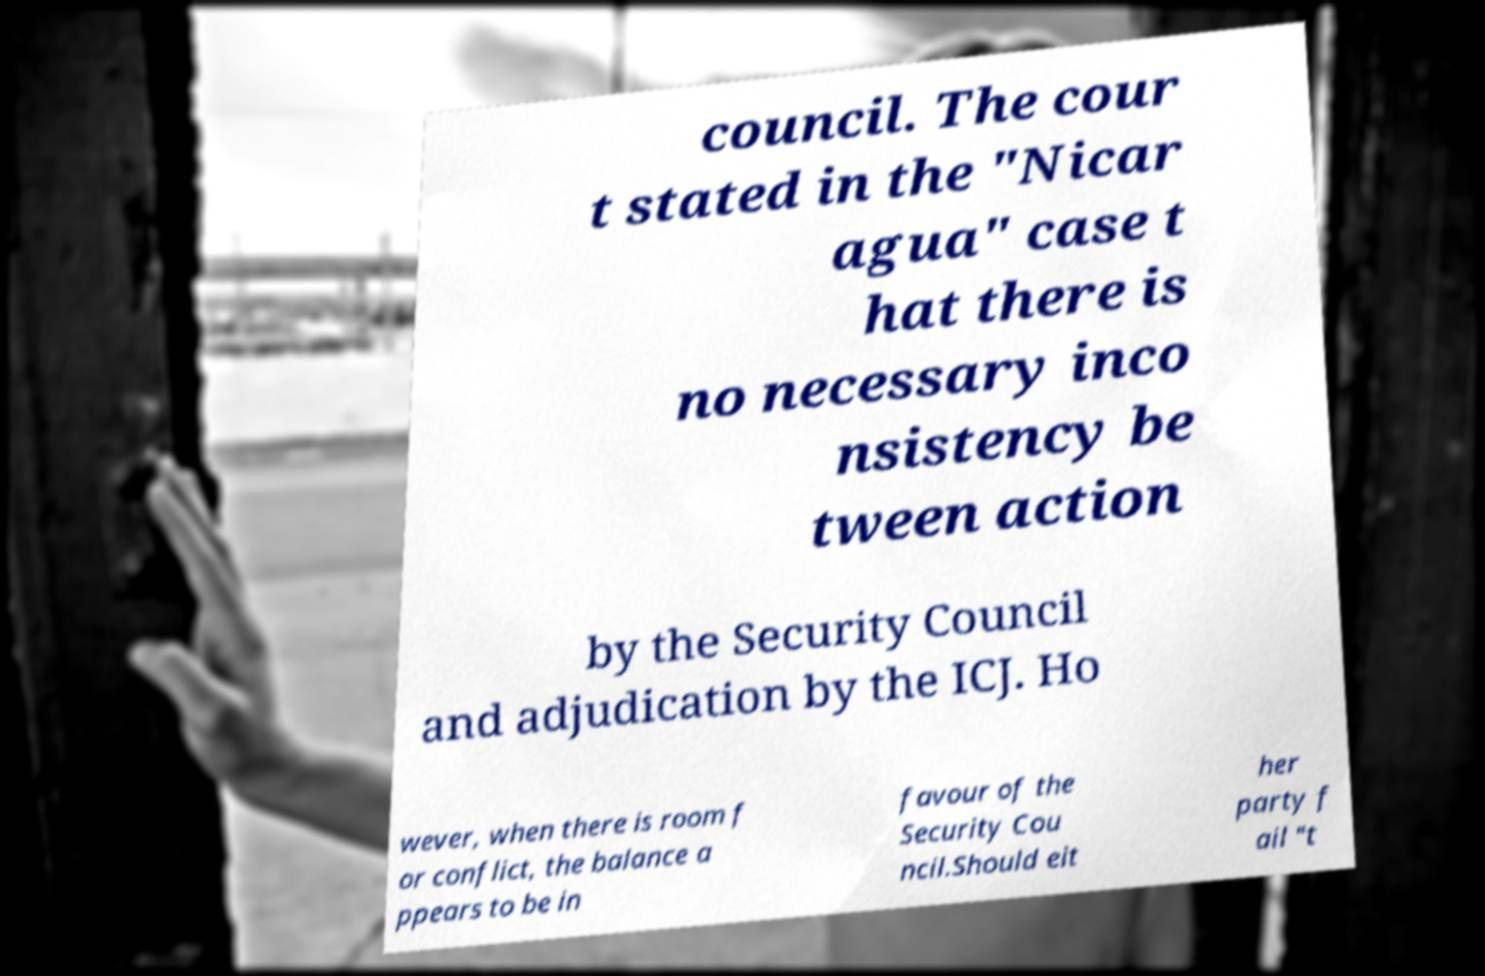There's text embedded in this image that I need extracted. Can you transcribe it verbatim? council. The cour t stated in the "Nicar agua" case t hat there is no necessary inco nsistency be tween action by the Security Council and adjudication by the ICJ. Ho wever, when there is room f or conflict, the balance a ppears to be in favour of the Security Cou ncil.Should eit her party f ail "t 